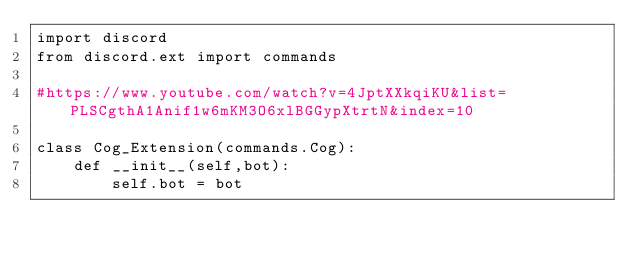Convert code to text. <code><loc_0><loc_0><loc_500><loc_500><_Python_>import discord
from discord.ext import commands

#https://www.youtube.com/watch?v=4JptXXkqiKU&list=PLSCgthA1Anif1w6mKM3O6xlBGGypXtrtN&index=10

class Cog_Extension(commands.Cog):
    def __init__(self,bot):
        self.bot = bot
</code> 